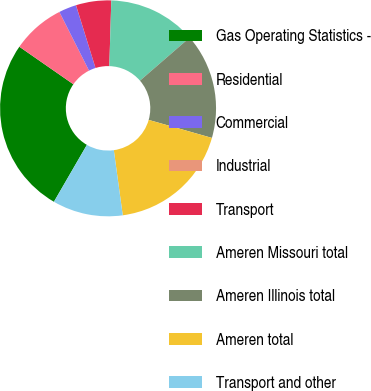Convert chart. <chart><loc_0><loc_0><loc_500><loc_500><pie_chart><fcel>Gas Operating Statistics -<fcel>Residential<fcel>Commercial<fcel>Industrial<fcel>Transport<fcel>Ameren Missouri total<fcel>Ameren Illinois total<fcel>Ameren total<fcel>Transport and other<nl><fcel>26.3%<fcel>7.9%<fcel>2.64%<fcel>0.01%<fcel>5.27%<fcel>13.16%<fcel>15.78%<fcel>18.41%<fcel>10.53%<nl></chart> 